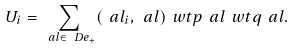Convert formula to latex. <formula><loc_0><loc_0><loc_500><loc_500>U _ { i } = \sum _ { \ a l \in \ D e _ { + } } ( \ a l _ { i } , \ a l ) \ w t { p } _ { \ } a l \ w t { q } _ { \ } a l .</formula> 